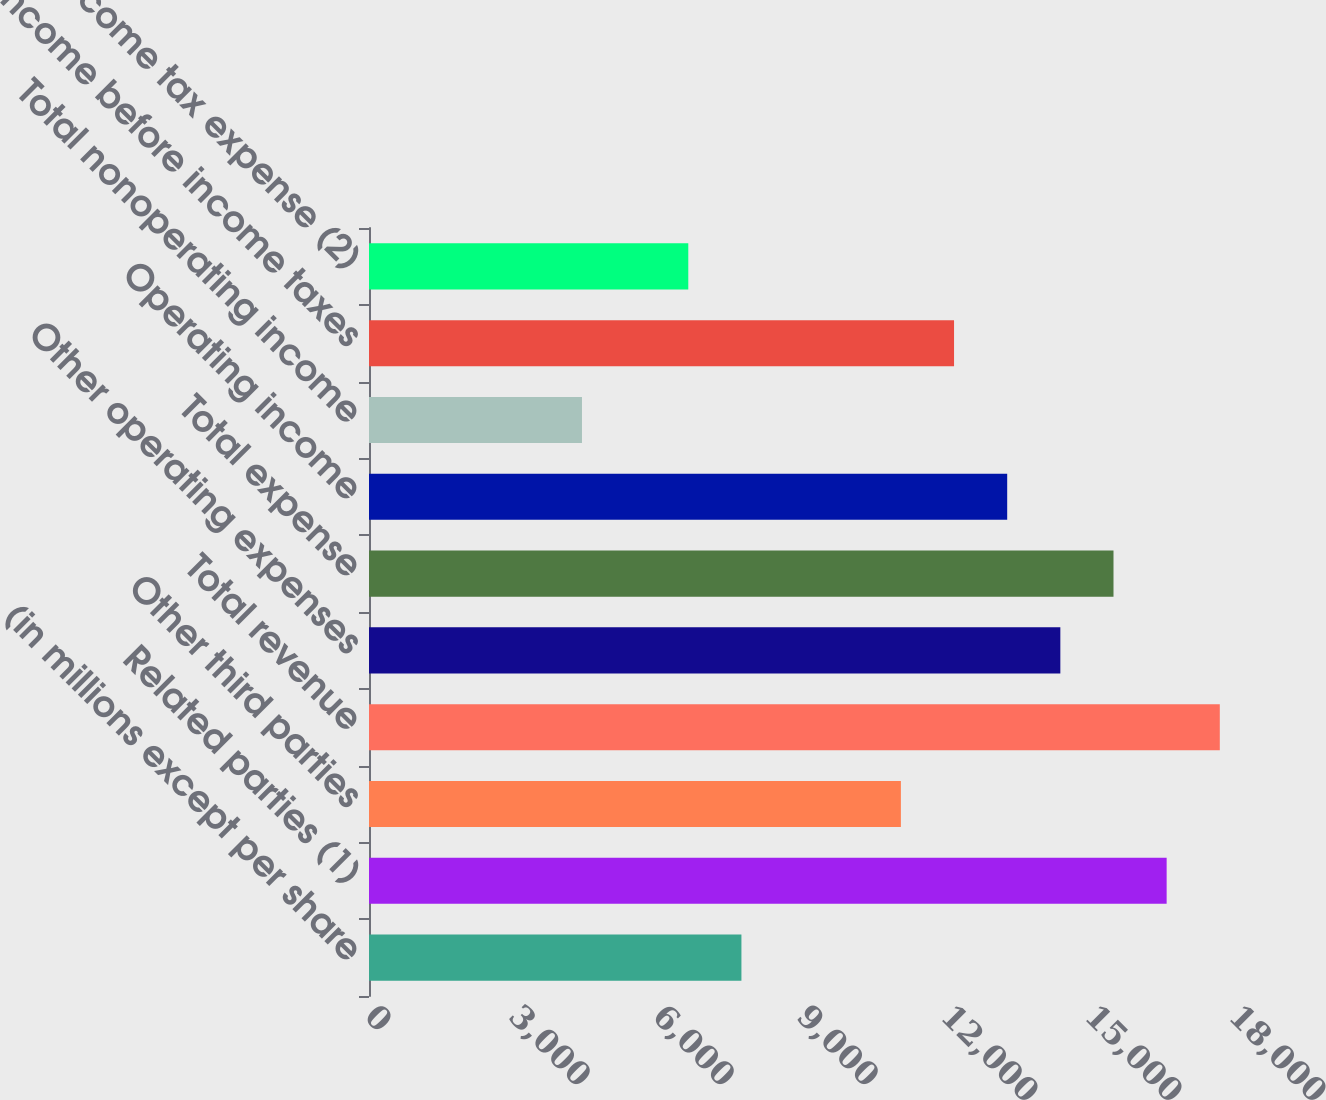Convert chart to OTSL. <chart><loc_0><loc_0><loc_500><loc_500><bar_chart><fcel>(in millions except per share<fcel>Related parties (1)<fcel>Other third parties<fcel>Total revenue<fcel>Other operating expenses<fcel>Total expense<fcel>Operating income<fcel>Total nonoperating income<fcel>Income before income taxes<fcel>Income tax expense (2)<nl><fcel>7759.03<fcel>16617.7<fcel>11081<fcel>17725<fcel>14403<fcel>15510.3<fcel>13295.7<fcel>4437.04<fcel>12188.4<fcel>6651.7<nl></chart> 